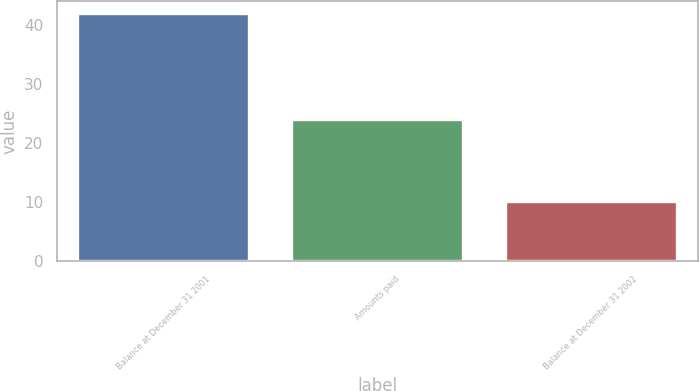Convert chart. <chart><loc_0><loc_0><loc_500><loc_500><bar_chart><fcel>Balance at December 31 2001<fcel>Amounts paid<fcel>Balance at December 31 2002<nl><fcel>42<fcel>24<fcel>10<nl></chart> 